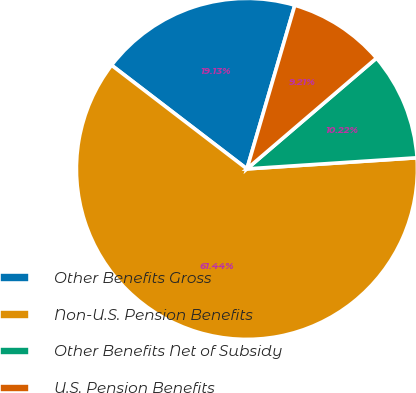Convert chart to OTSL. <chart><loc_0><loc_0><loc_500><loc_500><pie_chart><fcel>Other Benefits Gross<fcel>Non-U.S. Pension Benefits<fcel>Other Benefits Net of Subsidy<fcel>U.S. Pension Benefits<nl><fcel>19.13%<fcel>61.44%<fcel>10.22%<fcel>9.21%<nl></chart> 